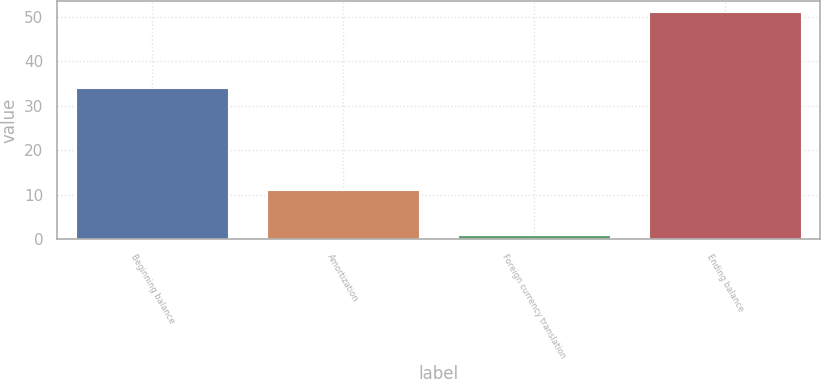Convert chart to OTSL. <chart><loc_0><loc_0><loc_500><loc_500><bar_chart><fcel>Beginning balance<fcel>Amortization<fcel>Foreign currency translation<fcel>Ending balance<nl><fcel>34<fcel>11<fcel>1<fcel>51<nl></chart> 